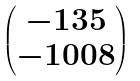<formula> <loc_0><loc_0><loc_500><loc_500>\begin{pmatrix} - 1 3 5 \\ - 1 0 0 8 \end{pmatrix}</formula> 